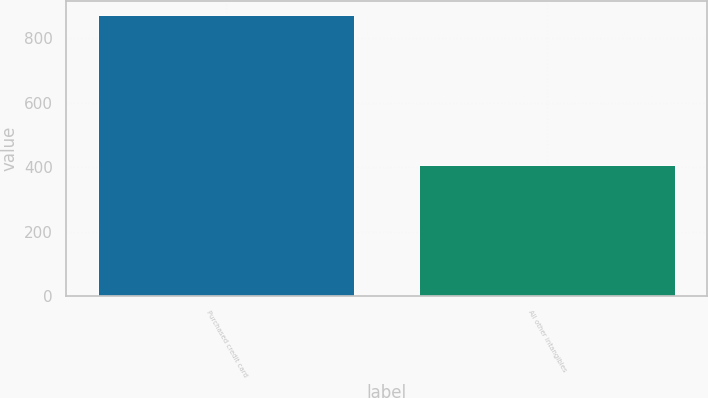<chart> <loc_0><loc_0><loc_500><loc_500><bar_chart><fcel>Purchased credit card<fcel>All other intangibles<nl><fcel>871<fcel>408<nl></chart> 